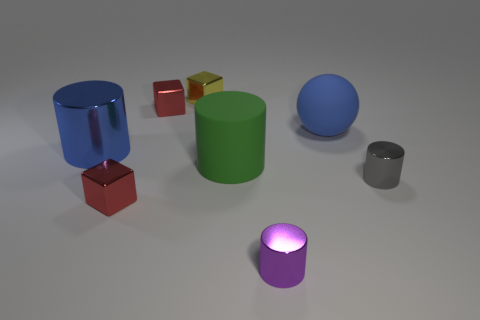Add 2 large blue shiny cylinders. How many objects exist? 10 Subtract all spheres. How many objects are left? 7 Add 5 purple metal cylinders. How many purple metal cylinders are left? 6 Add 2 tiny blocks. How many tiny blocks exist? 5 Subtract 0 cyan blocks. How many objects are left? 8 Subtract all cubes. Subtract all green objects. How many objects are left? 4 